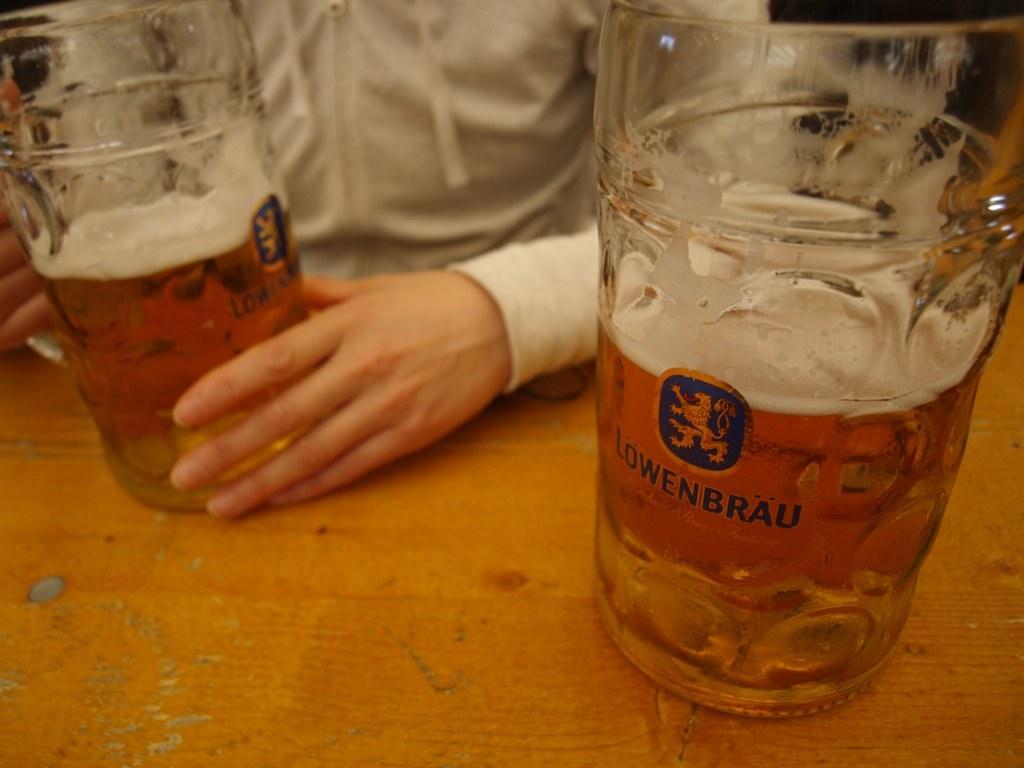What type of drink are they drinking?
Offer a very short reply. Lowenbrau. 